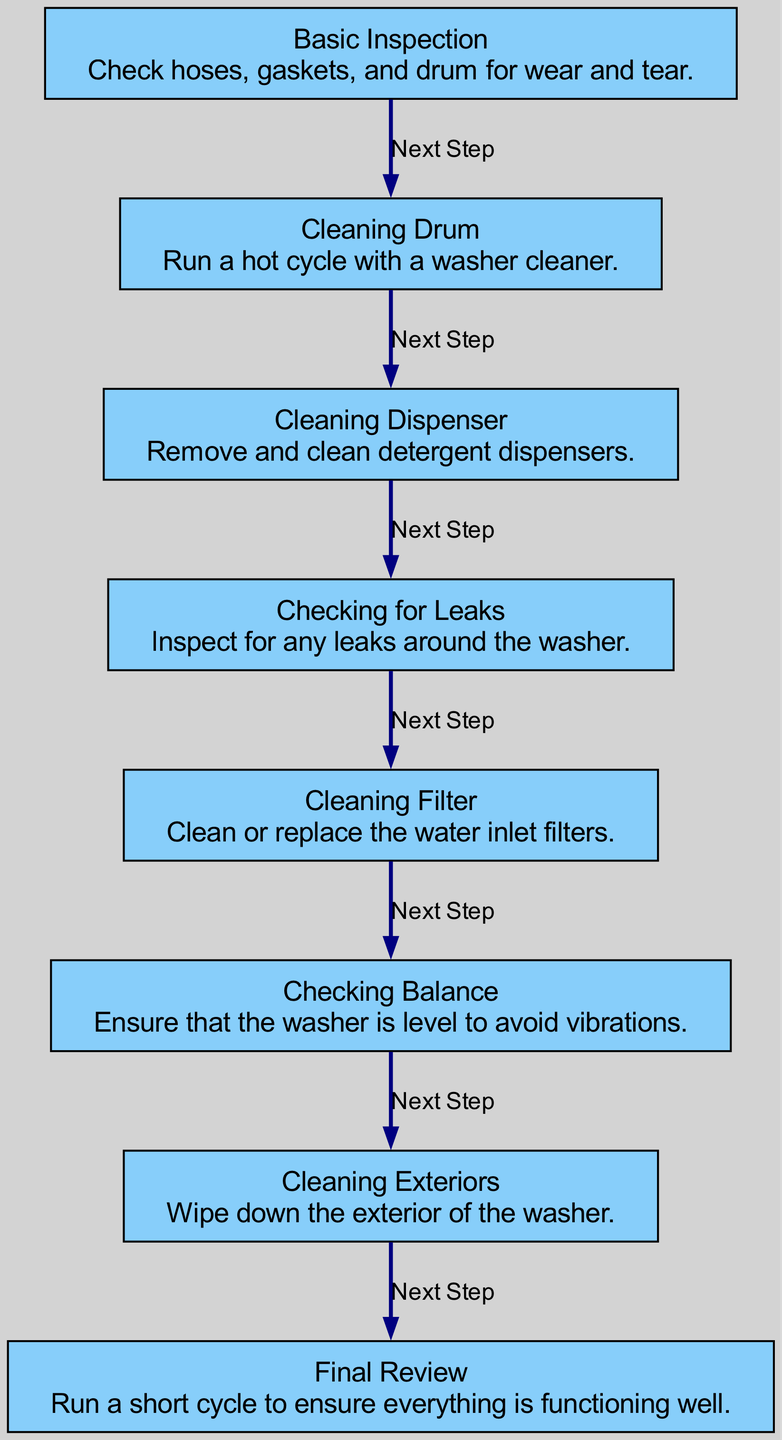What is the first step in the maintenance schedule? The first step in the diagram is "Basic Inspection," which is the initial task outlined for the maintenance schedule.
Answer: Basic Inspection How many total steps are outlined in the diagram? The diagram shows a total of seven steps, as indicated by the nodes present leading to the final review.
Answer: Seven What follows after cleaning the dispenser? The diagram indicates that after "Cleaning Dispenser," the next step is "Checking for Leaks."
Answer: Checking for Leaks What task is to be done before cleaning the filter? The diagram specifies that "Checking for Leaks" must be completed before proceeding to "Cleaning Filter."
Answer: Checking for Leaks Which step comes directly after cleaning the exteriors? According to the diagram, "Final Review" is the step that follows "Cleaning Exteriors."
Answer: Final Review What is the last step in the maintenance schedule? The last step presented in the diagram is "Final Review," which is the concluding task to ensure all is functioning correctly.
Answer: Final Review Which steps involve cleaning? The steps that involve cleaning are "Cleaning Drum," "Cleaning Dispenser," "Cleaning Filter," and "Cleaning Exteriors."
Answer: Cleaning Drum, Cleaning Dispenser, Cleaning Filter, Cleaning Exteriors What must be ensured before proceeding to clean the exteriors? The diagram states that "Checking Balance" needs to be completed before "Cleaning Exteriors."
Answer: Checking Balance What is the outcome after performing a basic inspection? After performing "Basic Inspection," the next step is "Cleaning Drum," indicating it leads to this action.
Answer: Cleaning Drum 